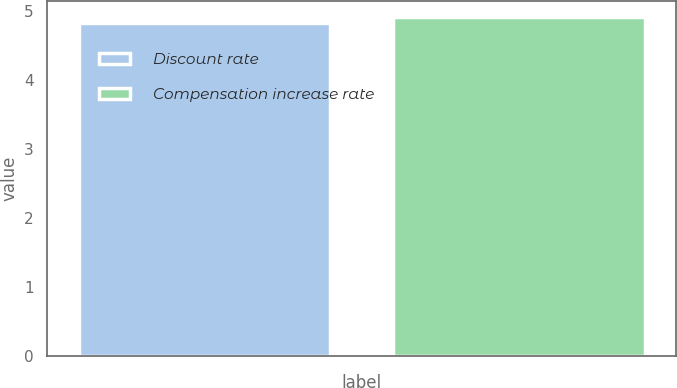Convert chart. <chart><loc_0><loc_0><loc_500><loc_500><bar_chart><fcel>Discount rate<fcel>Compensation increase rate<nl><fcel>4.83<fcel>4.91<nl></chart> 